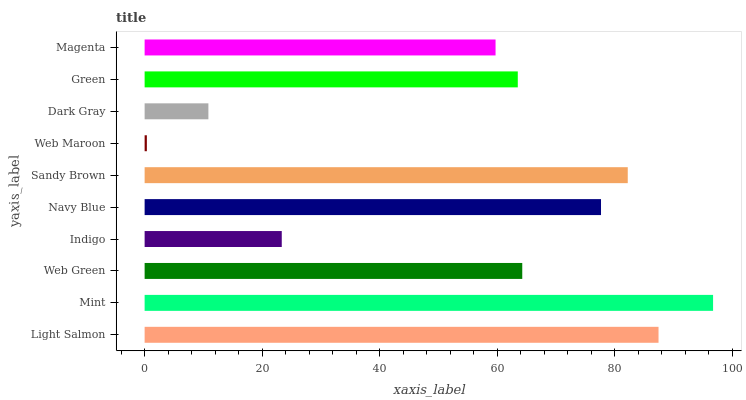Is Web Maroon the minimum?
Answer yes or no. Yes. Is Mint the maximum?
Answer yes or no. Yes. Is Web Green the minimum?
Answer yes or no. No. Is Web Green the maximum?
Answer yes or no. No. Is Mint greater than Web Green?
Answer yes or no. Yes. Is Web Green less than Mint?
Answer yes or no. Yes. Is Web Green greater than Mint?
Answer yes or no. No. Is Mint less than Web Green?
Answer yes or no. No. Is Web Green the high median?
Answer yes or no. Yes. Is Green the low median?
Answer yes or no. Yes. Is Light Salmon the high median?
Answer yes or no. No. Is Light Salmon the low median?
Answer yes or no. No. 